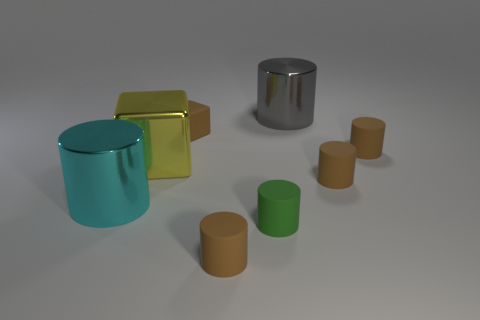How many brown cylinders must be subtracted to get 1 brown cylinders? 2 Subtract all brown spheres. How many brown cylinders are left? 3 Subtract 3 cylinders. How many cylinders are left? 3 Subtract all gray cylinders. How many cylinders are left? 5 Subtract all large cyan cylinders. How many cylinders are left? 5 Subtract all yellow cylinders. Subtract all yellow spheres. How many cylinders are left? 6 Add 1 yellow shiny objects. How many objects exist? 9 Subtract all blocks. How many objects are left? 6 Subtract 1 cyan cylinders. How many objects are left? 7 Subtract all things. Subtract all small red metallic blocks. How many objects are left? 0 